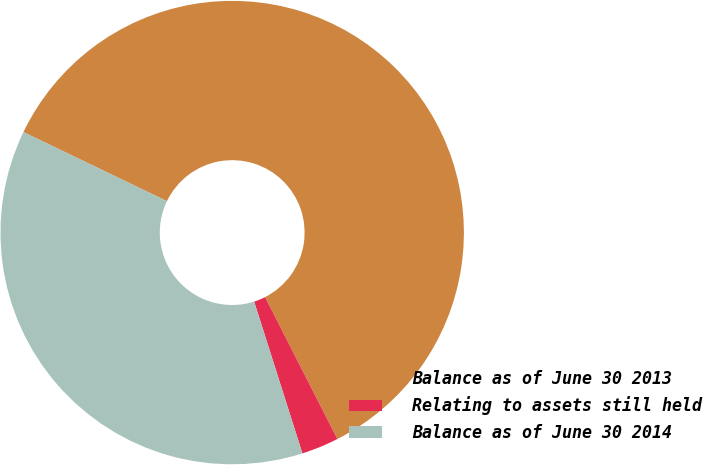Convert chart to OTSL. <chart><loc_0><loc_0><loc_500><loc_500><pie_chart><fcel>Balance as of June 30 2013<fcel>Relating to assets still held<fcel>Balance as of June 30 2014<nl><fcel>60.36%<fcel>2.6%<fcel>37.04%<nl></chart> 